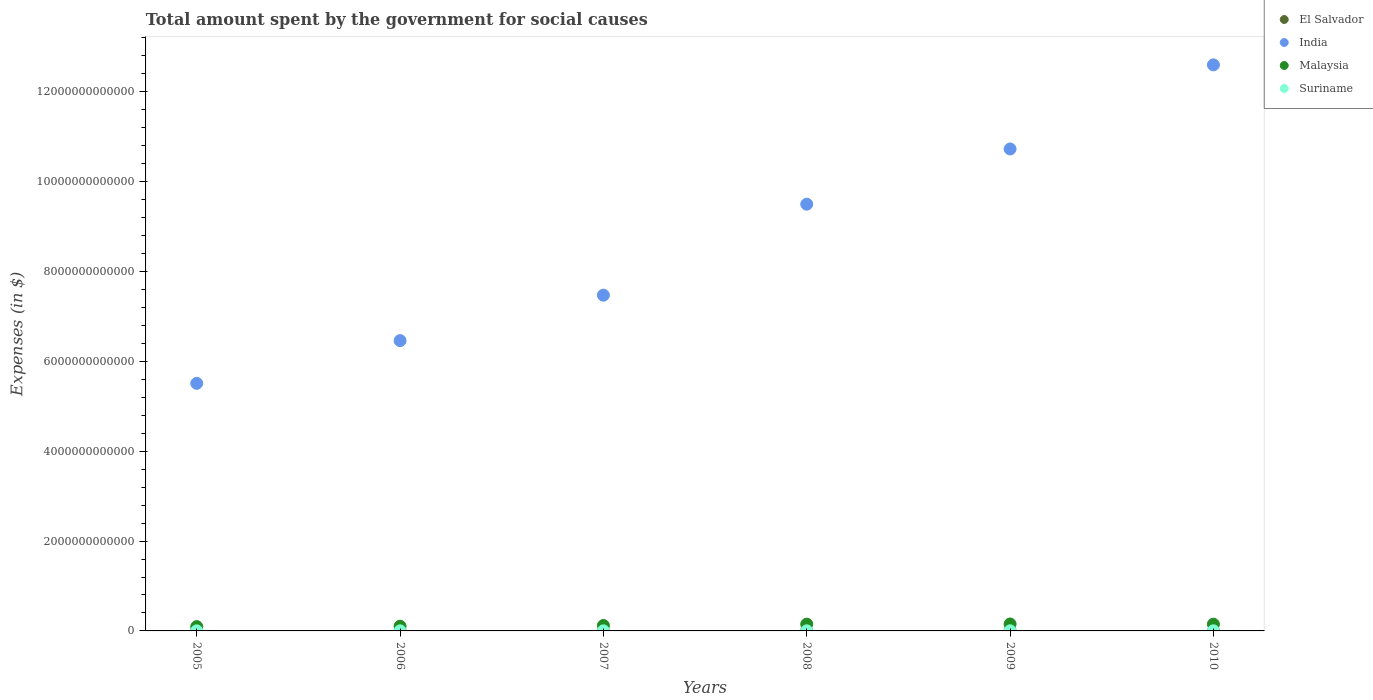Is the number of dotlines equal to the number of legend labels?
Keep it short and to the point. Yes. What is the amount spent for social causes by the government in Malaysia in 2005?
Your response must be concise. 9.61e+1. Across all years, what is the maximum amount spent for social causes by the government in El Salvador?
Offer a terse response. 4.55e+09. Across all years, what is the minimum amount spent for social causes by the government in India?
Give a very brief answer. 5.51e+12. In which year was the amount spent for social causes by the government in El Salvador maximum?
Make the answer very short. 2009. What is the total amount spent for social causes by the government in El Salvador in the graph?
Offer a terse response. 2.32e+1. What is the difference between the amount spent for social causes by the government in El Salvador in 2006 and that in 2007?
Your answer should be very brief. 1.10e+08. What is the difference between the amount spent for social causes by the government in Malaysia in 2005 and the amount spent for social causes by the government in Suriname in 2007?
Your answer should be very brief. 9.43e+1. What is the average amount spent for social causes by the government in El Salvador per year?
Offer a very short reply. 3.87e+09. In the year 2010, what is the difference between the amount spent for social causes by the government in Malaysia and amount spent for social causes by the government in El Salvador?
Provide a short and direct response. 1.45e+11. What is the ratio of the amount spent for social causes by the government in El Salvador in 2005 to that in 2007?
Keep it short and to the point. 0.86. Is the difference between the amount spent for social causes by the government in Malaysia in 2007 and 2008 greater than the difference between the amount spent for social causes by the government in El Salvador in 2007 and 2008?
Provide a succinct answer. No. What is the difference between the highest and the second highest amount spent for social causes by the government in Suriname?
Provide a short and direct response. 3.39e+07. What is the difference between the highest and the lowest amount spent for social causes by the government in India?
Make the answer very short. 7.09e+12. In how many years, is the amount spent for social causes by the government in El Salvador greater than the average amount spent for social causes by the government in El Salvador taken over all years?
Your answer should be very brief. 3. Is the sum of the amount spent for social causes by the government in Suriname in 2006 and 2007 greater than the maximum amount spent for social causes by the government in India across all years?
Provide a short and direct response. No. Does the amount spent for social causes by the government in India monotonically increase over the years?
Ensure brevity in your answer.  Yes. Is the amount spent for social causes by the government in Suriname strictly greater than the amount spent for social causes by the government in El Salvador over the years?
Give a very brief answer. No. How many dotlines are there?
Make the answer very short. 4. How many years are there in the graph?
Your response must be concise. 6. What is the difference between two consecutive major ticks on the Y-axis?
Make the answer very short. 2.00e+12. Are the values on the major ticks of Y-axis written in scientific E-notation?
Provide a short and direct response. No. Does the graph contain grids?
Keep it short and to the point. No. How are the legend labels stacked?
Keep it short and to the point. Vertical. What is the title of the graph?
Offer a very short reply. Total amount spent by the government for social causes. Does "Latin America(developing only)" appear as one of the legend labels in the graph?
Keep it short and to the point. No. What is the label or title of the Y-axis?
Your response must be concise. Expenses (in $). What is the Expenses (in $) of El Salvador in 2005?
Make the answer very short. 3.01e+09. What is the Expenses (in $) in India in 2005?
Make the answer very short. 5.51e+12. What is the Expenses (in $) in Malaysia in 2005?
Your response must be concise. 9.61e+1. What is the Expenses (in $) of Suriname in 2005?
Provide a short and direct response. 1.28e+09. What is the Expenses (in $) of El Salvador in 2006?
Ensure brevity in your answer.  3.60e+09. What is the Expenses (in $) of India in 2006?
Offer a terse response. 6.46e+12. What is the Expenses (in $) in Malaysia in 2006?
Your response must be concise. 1.06e+11. What is the Expenses (in $) in Suriname in 2006?
Ensure brevity in your answer.  1.63e+09. What is the Expenses (in $) in El Salvador in 2007?
Provide a short and direct response. 3.49e+09. What is the Expenses (in $) of India in 2007?
Ensure brevity in your answer.  7.47e+12. What is the Expenses (in $) in Malaysia in 2007?
Your answer should be very brief. 1.21e+11. What is the Expenses (in $) in Suriname in 2007?
Keep it short and to the point. 1.82e+09. What is the Expenses (in $) of El Salvador in 2008?
Make the answer very short. 4.09e+09. What is the Expenses (in $) of India in 2008?
Ensure brevity in your answer.  9.50e+12. What is the Expenses (in $) of Malaysia in 2008?
Offer a terse response. 1.51e+11. What is the Expenses (in $) in Suriname in 2008?
Give a very brief answer. 1.99e+09. What is the Expenses (in $) in El Salvador in 2009?
Provide a succinct answer. 4.55e+09. What is the Expenses (in $) of India in 2009?
Offer a very short reply. 1.07e+13. What is the Expenses (in $) of Malaysia in 2009?
Make the answer very short. 1.54e+11. What is the Expenses (in $) in Suriname in 2009?
Provide a succinct answer. 2.47e+09. What is the Expenses (in $) of El Salvador in 2010?
Keep it short and to the point. 4.45e+09. What is the Expenses (in $) of India in 2010?
Ensure brevity in your answer.  1.26e+13. What is the Expenses (in $) of Malaysia in 2010?
Your response must be concise. 1.50e+11. What is the Expenses (in $) in Suriname in 2010?
Ensure brevity in your answer.  2.50e+09. Across all years, what is the maximum Expenses (in $) of El Salvador?
Make the answer very short. 4.55e+09. Across all years, what is the maximum Expenses (in $) in India?
Offer a terse response. 1.26e+13. Across all years, what is the maximum Expenses (in $) in Malaysia?
Your response must be concise. 1.54e+11. Across all years, what is the maximum Expenses (in $) in Suriname?
Your response must be concise. 2.50e+09. Across all years, what is the minimum Expenses (in $) of El Salvador?
Your response must be concise. 3.01e+09. Across all years, what is the minimum Expenses (in $) in India?
Your answer should be very brief. 5.51e+12. Across all years, what is the minimum Expenses (in $) of Malaysia?
Offer a terse response. 9.61e+1. Across all years, what is the minimum Expenses (in $) of Suriname?
Keep it short and to the point. 1.28e+09. What is the total Expenses (in $) in El Salvador in the graph?
Keep it short and to the point. 2.32e+1. What is the total Expenses (in $) in India in the graph?
Offer a very short reply. 5.23e+13. What is the total Expenses (in $) of Malaysia in the graph?
Provide a succinct answer. 7.77e+11. What is the total Expenses (in $) in Suriname in the graph?
Keep it short and to the point. 1.17e+1. What is the difference between the Expenses (in $) in El Salvador in 2005 and that in 2006?
Provide a short and direct response. -5.95e+08. What is the difference between the Expenses (in $) of India in 2005 and that in 2006?
Provide a succinct answer. -9.51e+11. What is the difference between the Expenses (in $) in Malaysia in 2005 and that in 2006?
Keep it short and to the point. -9.60e+09. What is the difference between the Expenses (in $) in Suriname in 2005 and that in 2006?
Your answer should be compact. -3.43e+08. What is the difference between the Expenses (in $) of El Salvador in 2005 and that in 2007?
Offer a terse response. -4.85e+08. What is the difference between the Expenses (in $) of India in 2005 and that in 2007?
Provide a short and direct response. -1.96e+12. What is the difference between the Expenses (in $) in Malaysia in 2005 and that in 2007?
Ensure brevity in your answer.  -2.44e+1. What is the difference between the Expenses (in $) of Suriname in 2005 and that in 2007?
Offer a terse response. -5.36e+08. What is the difference between the Expenses (in $) in El Salvador in 2005 and that in 2008?
Offer a very short reply. -1.08e+09. What is the difference between the Expenses (in $) of India in 2005 and that in 2008?
Your answer should be very brief. -3.99e+12. What is the difference between the Expenses (in $) of Malaysia in 2005 and that in 2008?
Offer a terse response. -5.45e+1. What is the difference between the Expenses (in $) of Suriname in 2005 and that in 2008?
Ensure brevity in your answer.  -7.04e+08. What is the difference between the Expenses (in $) in El Salvador in 2005 and that in 2009?
Make the answer very short. -1.54e+09. What is the difference between the Expenses (in $) of India in 2005 and that in 2009?
Your answer should be compact. -5.22e+12. What is the difference between the Expenses (in $) in Malaysia in 2005 and that in 2009?
Offer a terse response. -5.83e+1. What is the difference between the Expenses (in $) of Suriname in 2005 and that in 2009?
Provide a short and direct response. -1.18e+09. What is the difference between the Expenses (in $) of El Salvador in 2005 and that in 2010?
Your answer should be compact. -1.44e+09. What is the difference between the Expenses (in $) in India in 2005 and that in 2010?
Your answer should be very brief. -7.09e+12. What is the difference between the Expenses (in $) of Malaysia in 2005 and that in 2010?
Offer a very short reply. -5.36e+1. What is the difference between the Expenses (in $) in Suriname in 2005 and that in 2010?
Offer a terse response. -1.22e+09. What is the difference between the Expenses (in $) of El Salvador in 2006 and that in 2007?
Offer a very short reply. 1.10e+08. What is the difference between the Expenses (in $) in India in 2006 and that in 2007?
Provide a short and direct response. -1.01e+12. What is the difference between the Expenses (in $) in Malaysia in 2006 and that in 2007?
Provide a succinct answer. -1.48e+1. What is the difference between the Expenses (in $) of Suriname in 2006 and that in 2007?
Make the answer very short. -1.93e+08. What is the difference between the Expenses (in $) of El Salvador in 2006 and that in 2008?
Give a very brief answer. -4.88e+08. What is the difference between the Expenses (in $) of India in 2006 and that in 2008?
Provide a succinct answer. -3.04e+12. What is the difference between the Expenses (in $) of Malaysia in 2006 and that in 2008?
Ensure brevity in your answer.  -4.49e+1. What is the difference between the Expenses (in $) of Suriname in 2006 and that in 2008?
Your answer should be compact. -3.61e+08. What is the difference between the Expenses (in $) of El Salvador in 2006 and that in 2009?
Offer a very short reply. -9.46e+08. What is the difference between the Expenses (in $) of India in 2006 and that in 2009?
Ensure brevity in your answer.  -4.27e+12. What is the difference between the Expenses (in $) of Malaysia in 2006 and that in 2009?
Your answer should be very brief. -4.87e+1. What is the difference between the Expenses (in $) of Suriname in 2006 and that in 2009?
Make the answer very short. -8.41e+08. What is the difference between the Expenses (in $) of El Salvador in 2006 and that in 2010?
Provide a succinct answer. -8.50e+08. What is the difference between the Expenses (in $) in India in 2006 and that in 2010?
Offer a terse response. -6.14e+12. What is the difference between the Expenses (in $) in Malaysia in 2006 and that in 2010?
Your answer should be very brief. -4.40e+1. What is the difference between the Expenses (in $) of Suriname in 2006 and that in 2010?
Your response must be concise. -8.75e+08. What is the difference between the Expenses (in $) in El Salvador in 2007 and that in 2008?
Give a very brief answer. -5.98e+08. What is the difference between the Expenses (in $) in India in 2007 and that in 2008?
Keep it short and to the point. -2.03e+12. What is the difference between the Expenses (in $) of Malaysia in 2007 and that in 2008?
Your response must be concise. -3.01e+1. What is the difference between the Expenses (in $) of Suriname in 2007 and that in 2008?
Make the answer very short. -1.68e+08. What is the difference between the Expenses (in $) in El Salvador in 2007 and that in 2009?
Ensure brevity in your answer.  -1.06e+09. What is the difference between the Expenses (in $) of India in 2007 and that in 2009?
Offer a terse response. -3.25e+12. What is the difference between the Expenses (in $) of Malaysia in 2007 and that in 2009?
Ensure brevity in your answer.  -3.39e+1. What is the difference between the Expenses (in $) of Suriname in 2007 and that in 2009?
Your answer should be compact. -6.49e+08. What is the difference between the Expenses (in $) in El Salvador in 2007 and that in 2010?
Offer a very short reply. -9.60e+08. What is the difference between the Expenses (in $) of India in 2007 and that in 2010?
Your answer should be very brief. -5.13e+12. What is the difference between the Expenses (in $) of Malaysia in 2007 and that in 2010?
Make the answer very short. -2.92e+1. What is the difference between the Expenses (in $) in Suriname in 2007 and that in 2010?
Provide a succinct answer. -6.83e+08. What is the difference between the Expenses (in $) of El Salvador in 2008 and that in 2009?
Offer a terse response. -4.58e+08. What is the difference between the Expenses (in $) of India in 2008 and that in 2009?
Ensure brevity in your answer.  -1.23e+12. What is the difference between the Expenses (in $) in Malaysia in 2008 and that in 2009?
Your response must be concise. -3.82e+09. What is the difference between the Expenses (in $) of Suriname in 2008 and that in 2009?
Ensure brevity in your answer.  -4.80e+08. What is the difference between the Expenses (in $) of El Salvador in 2008 and that in 2010?
Offer a very short reply. -3.62e+08. What is the difference between the Expenses (in $) in India in 2008 and that in 2010?
Make the answer very short. -3.10e+12. What is the difference between the Expenses (in $) in Malaysia in 2008 and that in 2010?
Give a very brief answer. 9.00e+08. What is the difference between the Expenses (in $) in Suriname in 2008 and that in 2010?
Provide a succinct answer. -5.14e+08. What is the difference between the Expenses (in $) in El Salvador in 2009 and that in 2010?
Give a very brief answer. 9.62e+07. What is the difference between the Expenses (in $) of India in 2009 and that in 2010?
Offer a very short reply. -1.87e+12. What is the difference between the Expenses (in $) of Malaysia in 2009 and that in 2010?
Offer a terse response. 4.72e+09. What is the difference between the Expenses (in $) of Suriname in 2009 and that in 2010?
Make the answer very short. -3.39e+07. What is the difference between the Expenses (in $) of El Salvador in 2005 and the Expenses (in $) of India in 2006?
Your answer should be very brief. -6.46e+12. What is the difference between the Expenses (in $) in El Salvador in 2005 and the Expenses (in $) in Malaysia in 2006?
Provide a succinct answer. -1.03e+11. What is the difference between the Expenses (in $) in El Salvador in 2005 and the Expenses (in $) in Suriname in 2006?
Make the answer very short. 1.38e+09. What is the difference between the Expenses (in $) of India in 2005 and the Expenses (in $) of Malaysia in 2006?
Ensure brevity in your answer.  5.41e+12. What is the difference between the Expenses (in $) in India in 2005 and the Expenses (in $) in Suriname in 2006?
Your answer should be compact. 5.51e+12. What is the difference between the Expenses (in $) in Malaysia in 2005 and the Expenses (in $) in Suriname in 2006?
Give a very brief answer. 9.45e+1. What is the difference between the Expenses (in $) in El Salvador in 2005 and the Expenses (in $) in India in 2007?
Your answer should be compact. -7.47e+12. What is the difference between the Expenses (in $) of El Salvador in 2005 and the Expenses (in $) of Malaysia in 2007?
Give a very brief answer. -1.18e+11. What is the difference between the Expenses (in $) of El Salvador in 2005 and the Expenses (in $) of Suriname in 2007?
Your answer should be compact. 1.19e+09. What is the difference between the Expenses (in $) of India in 2005 and the Expenses (in $) of Malaysia in 2007?
Make the answer very short. 5.39e+12. What is the difference between the Expenses (in $) in India in 2005 and the Expenses (in $) in Suriname in 2007?
Your answer should be compact. 5.51e+12. What is the difference between the Expenses (in $) in Malaysia in 2005 and the Expenses (in $) in Suriname in 2007?
Offer a terse response. 9.43e+1. What is the difference between the Expenses (in $) in El Salvador in 2005 and the Expenses (in $) in India in 2008?
Make the answer very short. -9.50e+12. What is the difference between the Expenses (in $) in El Salvador in 2005 and the Expenses (in $) in Malaysia in 2008?
Give a very brief answer. -1.48e+11. What is the difference between the Expenses (in $) in El Salvador in 2005 and the Expenses (in $) in Suriname in 2008?
Your answer should be very brief. 1.02e+09. What is the difference between the Expenses (in $) of India in 2005 and the Expenses (in $) of Malaysia in 2008?
Offer a very short reply. 5.36e+12. What is the difference between the Expenses (in $) in India in 2005 and the Expenses (in $) in Suriname in 2008?
Ensure brevity in your answer.  5.51e+12. What is the difference between the Expenses (in $) of Malaysia in 2005 and the Expenses (in $) of Suriname in 2008?
Ensure brevity in your answer.  9.42e+1. What is the difference between the Expenses (in $) in El Salvador in 2005 and the Expenses (in $) in India in 2009?
Ensure brevity in your answer.  -1.07e+13. What is the difference between the Expenses (in $) of El Salvador in 2005 and the Expenses (in $) of Malaysia in 2009?
Provide a succinct answer. -1.51e+11. What is the difference between the Expenses (in $) of El Salvador in 2005 and the Expenses (in $) of Suriname in 2009?
Your answer should be compact. 5.42e+08. What is the difference between the Expenses (in $) in India in 2005 and the Expenses (in $) in Malaysia in 2009?
Keep it short and to the point. 5.36e+12. What is the difference between the Expenses (in $) in India in 2005 and the Expenses (in $) in Suriname in 2009?
Ensure brevity in your answer.  5.51e+12. What is the difference between the Expenses (in $) of Malaysia in 2005 and the Expenses (in $) of Suriname in 2009?
Make the answer very short. 9.37e+1. What is the difference between the Expenses (in $) of El Salvador in 2005 and the Expenses (in $) of India in 2010?
Give a very brief answer. -1.26e+13. What is the difference between the Expenses (in $) of El Salvador in 2005 and the Expenses (in $) of Malaysia in 2010?
Your answer should be compact. -1.47e+11. What is the difference between the Expenses (in $) in El Salvador in 2005 and the Expenses (in $) in Suriname in 2010?
Offer a terse response. 5.08e+08. What is the difference between the Expenses (in $) of India in 2005 and the Expenses (in $) of Malaysia in 2010?
Your response must be concise. 5.36e+12. What is the difference between the Expenses (in $) in India in 2005 and the Expenses (in $) in Suriname in 2010?
Your answer should be compact. 5.51e+12. What is the difference between the Expenses (in $) in Malaysia in 2005 and the Expenses (in $) in Suriname in 2010?
Offer a terse response. 9.36e+1. What is the difference between the Expenses (in $) of El Salvador in 2006 and the Expenses (in $) of India in 2007?
Offer a terse response. -7.47e+12. What is the difference between the Expenses (in $) in El Salvador in 2006 and the Expenses (in $) in Malaysia in 2007?
Provide a succinct answer. -1.17e+11. What is the difference between the Expenses (in $) in El Salvador in 2006 and the Expenses (in $) in Suriname in 2007?
Offer a very short reply. 1.79e+09. What is the difference between the Expenses (in $) in India in 2006 and the Expenses (in $) in Malaysia in 2007?
Keep it short and to the point. 6.34e+12. What is the difference between the Expenses (in $) of India in 2006 and the Expenses (in $) of Suriname in 2007?
Your response must be concise. 6.46e+12. What is the difference between the Expenses (in $) of Malaysia in 2006 and the Expenses (in $) of Suriname in 2007?
Your answer should be very brief. 1.04e+11. What is the difference between the Expenses (in $) of El Salvador in 2006 and the Expenses (in $) of India in 2008?
Your response must be concise. -9.50e+12. What is the difference between the Expenses (in $) in El Salvador in 2006 and the Expenses (in $) in Malaysia in 2008?
Provide a succinct answer. -1.47e+11. What is the difference between the Expenses (in $) in El Salvador in 2006 and the Expenses (in $) in Suriname in 2008?
Offer a very short reply. 1.62e+09. What is the difference between the Expenses (in $) in India in 2006 and the Expenses (in $) in Malaysia in 2008?
Your answer should be compact. 6.31e+12. What is the difference between the Expenses (in $) in India in 2006 and the Expenses (in $) in Suriname in 2008?
Keep it short and to the point. 6.46e+12. What is the difference between the Expenses (in $) of Malaysia in 2006 and the Expenses (in $) of Suriname in 2008?
Give a very brief answer. 1.04e+11. What is the difference between the Expenses (in $) in El Salvador in 2006 and the Expenses (in $) in India in 2009?
Make the answer very short. -1.07e+13. What is the difference between the Expenses (in $) in El Salvador in 2006 and the Expenses (in $) in Malaysia in 2009?
Your answer should be compact. -1.51e+11. What is the difference between the Expenses (in $) of El Salvador in 2006 and the Expenses (in $) of Suriname in 2009?
Offer a terse response. 1.14e+09. What is the difference between the Expenses (in $) in India in 2006 and the Expenses (in $) in Malaysia in 2009?
Provide a short and direct response. 6.31e+12. What is the difference between the Expenses (in $) in India in 2006 and the Expenses (in $) in Suriname in 2009?
Offer a terse response. 6.46e+12. What is the difference between the Expenses (in $) in Malaysia in 2006 and the Expenses (in $) in Suriname in 2009?
Offer a very short reply. 1.03e+11. What is the difference between the Expenses (in $) in El Salvador in 2006 and the Expenses (in $) in India in 2010?
Make the answer very short. -1.26e+13. What is the difference between the Expenses (in $) of El Salvador in 2006 and the Expenses (in $) of Malaysia in 2010?
Ensure brevity in your answer.  -1.46e+11. What is the difference between the Expenses (in $) of El Salvador in 2006 and the Expenses (in $) of Suriname in 2010?
Give a very brief answer. 1.10e+09. What is the difference between the Expenses (in $) in India in 2006 and the Expenses (in $) in Malaysia in 2010?
Provide a short and direct response. 6.31e+12. What is the difference between the Expenses (in $) in India in 2006 and the Expenses (in $) in Suriname in 2010?
Make the answer very short. 6.46e+12. What is the difference between the Expenses (in $) in Malaysia in 2006 and the Expenses (in $) in Suriname in 2010?
Your answer should be compact. 1.03e+11. What is the difference between the Expenses (in $) in El Salvador in 2007 and the Expenses (in $) in India in 2008?
Provide a short and direct response. -9.50e+12. What is the difference between the Expenses (in $) in El Salvador in 2007 and the Expenses (in $) in Malaysia in 2008?
Keep it short and to the point. -1.47e+11. What is the difference between the Expenses (in $) in El Salvador in 2007 and the Expenses (in $) in Suriname in 2008?
Provide a short and direct response. 1.51e+09. What is the difference between the Expenses (in $) in India in 2007 and the Expenses (in $) in Malaysia in 2008?
Your response must be concise. 7.32e+12. What is the difference between the Expenses (in $) of India in 2007 and the Expenses (in $) of Suriname in 2008?
Your answer should be compact. 7.47e+12. What is the difference between the Expenses (in $) of Malaysia in 2007 and the Expenses (in $) of Suriname in 2008?
Keep it short and to the point. 1.19e+11. What is the difference between the Expenses (in $) of El Salvador in 2007 and the Expenses (in $) of India in 2009?
Offer a terse response. -1.07e+13. What is the difference between the Expenses (in $) of El Salvador in 2007 and the Expenses (in $) of Malaysia in 2009?
Keep it short and to the point. -1.51e+11. What is the difference between the Expenses (in $) in El Salvador in 2007 and the Expenses (in $) in Suriname in 2009?
Offer a very short reply. 1.03e+09. What is the difference between the Expenses (in $) of India in 2007 and the Expenses (in $) of Malaysia in 2009?
Your response must be concise. 7.32e+12. What is the difference between the Expenses (in $) in India in 2007 and the Expenses (in $) in Suriname in 2009?
Your answer should be very brief. 7.47e+12. What is the difference between the Expenses (in $) in Malaysia in 2007 and the Expenses (in $) in Suriname in 2009?
Offer a terse response. 1.18e+11. What is the difference between the Expenses (in $) in El Salvador in 2007 and the Expenses (in $) in India in 2010?
Your response must be concise. -1.26e+13. What is the difference between the Expenses (in $) in El Salvador in 2007 and the Expenses (in $) in Malaysia in 2010?
Offer a terse response. -1.46e+11. What is the difference between the Expenses (in $) of El Salvador in 2007 and the Expenses (in $) of Suriname in 2010?
Your answer should be very brief. 9.93e+08. What is the difference between the Expenses (in $) in India in 2007 and the Expenses (in $) in Malaysia in 2010?
Provide a short and direct response. 7.32e+12. What is the difference between the Expenses (in $) in India in 2007 and the Expenses (in $) in Suriname in 2010?
Provide a short and direct response. 7.47e+12. What is the difference between the Expenses (in $) in Malaysia in 2007 and the Expenses (in $) in Suriname in 2010?
Provide a succinct answer. 1.18e+11. What is the difference between the Expenses (in $) in El Salvador in 2008 and the Expenses (in $) in India in 2009?
Ensure brevity in your answer.  -1.07e+13. What is the difference between the Expenses (in $) of El Salvador in 2008 and the Expenses (in $) of Malaysia in 2009?
Give a very brief answer. -1.50e+11. What is the difference between the Expenses (in $) of El Salvador in 2008 and the Expenses (in $) of Suriname in 2009?
Offer a terse response. 1.62e+09. What is the difference between the Expenses (in $) in India in 2008 and the Expenses (in $) in Malaysia in 2009?
Offer a terse response. 9.35e+12. What is the difference between the Expenses (in $) in India in 2008 and the Expenses (in $) in Suriname in 2009?
Provide a succinct answer. 9.50e+12. What is the difference between the Expenses (in $) of Malaysia in 2008 and the Expenses (in $) of Suriname in 2009?
Make the answer very short. 1.48e+11. What is the difference between the Expenses (in $) of El Salvador in 2008 and the Expenses (in $) of India in 2010?
Ensure brevity in your answer.  -1.26e+13. What is the difference between the Expenses (in $) of El Salvador in 2008 and the Expenses (in $) of Malaysia in 2010?
Provide a short and direct response. -1.46e+11. What is the difference between the Expenses (in $) of El Salvador in 2008 and the Expenses (in $) of Suriname in 2010?
Your answer should be compact. 1.59e+09. What is the difference between the Expenses (in $) of India in 2008 and the Expenses (in $) of Malaysia in 2010?
Provide a succinct answer. 9.35e+12. What is the difference between the Expenses (in $) of India in 2008 and the Expenses (in $) of Suriname in 2010?
Keep it short and to the point. 9.50e+12. What is the difference between the Expenses (in $) in Malaysia in 2008 and the Expenses (in $) in Suriname in 2010?
Provide a short and direct response. 1.48e+11. What is the difference between the Expenses (in $) of El Salvador in 2009 and the Expenses (in $) of India in 2010?
Your answer should be very brief. -1.26e+13. What is the difference between the Expenses (in $) in El Salvador in 2009 and the Expenses (in $) in Malaysia in 2010?
Ensure brevity in your answer.  -1.45e+11. What is the difference between the Expenses (in $) in El Salvador in 2009 and the Expenses (in $) in Suriname in 2010?
Make the answer very short. 2.05e+09. What is the difference between the Expenses (in $) in India in 2009 and the Expenses (in $) in Malaysia in 2010?
Your response must be concise. 1.06e+13. What is the difference between the Expenses (in $) of India in 2009 and the Expenses (in $) of Suriname in 2010?
Offer a terse response. 1.07e+13. What is the difference between the Expenses (in $) in Malaysia in 2009 and the Expenses (in $) in Suriname in 2010?
Your response must be concise. 1.52e+11. What is the average Expenses (in $) of El Salvador per year?
Keep it short and to the point. 3.87e+09. What is the average Expenses (in $) in India per year?
Your answer should be very brief. 8.71e+12. What is the average Expenses (in $) in Malaysia per year?
Ensure brevity in your answer.  1.30e+11. What is the average Expenses (in $) in Suriname per year?
Your answer should be very brief. 1.95e+09. In the year 2005, what is the difference between the Expenses (in $) of El Salvador and Expenses (in $) of India?
Your answer should be very brief. -5.51e+12. In the year 2005, what is the difference between the Expenses (in $) in El Salvador and Expenses (in $) in Malaysia?
Offer a terse response. -9.31e+1. In the year 2005, what is the difference between the Expenses (in $) of El Salvador and Expenses (in $) of Suriname?
Give a very brief answer. 1.73e+09. In the year 2005, what is the difference between the Expenses (in $) of India and Expenses (in $) of Malaysia?
Provide a succinct answer. 5.42e+12. In the year 2005, what is the difference between the Expenses (in $) in India and Expenses (in $) in Suriname?
Give a very brief answer. 5.51e+12. In the year 2005, what is the difference between the Expenses (in $) in Malaysia and Expenses (in $) in Suriname?
Offer a very short reply. 9.49e+1. In the year 2006, what is the difference between the Expenses (in $) in El Salvador and Expenses (in $) in India?
Provide a succinct answer. -6.46e+12. In the year 2006, what is the difference between the Expenses (in $) of El Salvador and Expenses (in $) of Malaysia?
Your response must be concise. -1.02e+11. In the year 2006, what is the difference between the Expenses (in $) in El Salvador and Expenses (in $) in Suriname?
Your answer should be very brief. 1.98e+09. In the year 2006, what is the difference between the Expenses (in $) of India and Expenses (in $) of Malaysia?
Ensure brevity in your answer.  6.36e+12. In the year 2006, what is the difference between the Expenses (in $) in India and Expenses (in $) in Suriname?
Your answer should be very brief. 6.46e+12. In the year 2006, what is the difference between the Expenses (in $) of Malaysia and Expenses (in $) of Suriname?
Make the answer very short. 1.04e+11. In the year 2007, what is the difference between the Expenses (in $) in El Salvador and Expenses (in $) in India?
Your answer should be compact. -7.47e+12. In the year 2007, what is the difference between the Expenses (in $) in El Salvador and Expenses (in $) in Malaysia?
Your answer should be compact. -1.17e+11. In the year 2007, what is the difference between the Expenses (in $) of El Salvador and Expenses (in $) of Suriname?
Your response must be concise. 1.68e+09. In the year 2007, what is the difference between the Expenses (in $) of India and Expenses (in $) of Malaysia?
Your answer should be compact. 7.35e+12. In the year 2007, what is the difference between the Expenses (in $) in India and Expenses (in $) in Suriname?
Provide a short and direct response. 7.47e+12. In the year 2007, what is the difference between the Expenses (in $) of Malaysia and Expenses (in $) of Suriname?
Your response must be concise. 1.19e+11. In the year 2008, what is the difference between the Expenses (in $) in El Salvador and Expenses (in $) in India?
Provide a succinct answer. -9.50e+12. In the year 2008, what is the difference between the Expenses (in $) in El Salvador and Expenses (in $) in Malaysia?
Give a very brief answer. -1.47e+11. In the year 2008, what is the difference between the Expenses (in $) of El Salvador and Expenses (in $) of Suriname?
Provide a short and direct response. 2.10e+09. In the year 2008, what is the difference between the Expenses (in $) in India and Expenses (in $) in Malaysia?
Your response must be concise. 9.35e+12. In the year 2008, what is the difference between the Expenses (in $) in India and Expenses (in $) in Suriname?
Provide a short and direct response. 9.50e+12. In the year 2008, what is the difference between the Expenses (in $) in Malaysia and Expenses (in $) in Suriname?
Offer a terse response. 1.49e+11. In the year 2009, what is the difference between the Expenses (in $) in El Salvador and Expenses (in $) in India?
Keep it short and to the point. -1.07e+13. In the year 2009, what is the difference between the Expenses (in $) in El Salvador and Expenses (in $) in Malaysia?
Offer a terse response. -1.50e+11. In the year 2009, what is the difference between the Expenses (in $) of El Salvador and Expenses (in $) of Suriname?
Give a very brief answer. 2.08e+09. In the year 2009, what is the difference between the Expenses (in $) of India and Expenses (in $) of Malaysia?
Give a very brief answer. 1.06e+13. In the year 2009, what is the difference between the Expenses (in $) of India and Expenses (in $) of Suriname?
Make the answer very short. 1.07e+13. In the year 2009, what is the difference between the Expenses (in $) of Malaysia and Expenses (in $) of Suriname?
Your answer should be very brief. 1.52e+11. In the year 2010, what is the difference between the Expenses (in $) in El Salvador and Expenses (in $) in India?
Make the answer very short. -1.26e+13. In the year 2010, what is the difference between the Expenses (in $) of El Salvador and Expenses (in $) of Malaysia?
Keep it short and to the point. -1.45e+11. In the year 2010, what is the difference between the Expenses (in $) in El Salvador and Expenses (in $) in Suriname?
Make the answer very short. 1.95e+09. In the year 2010, what is the difference between the Expenses (in $) in India and Expenses (in $) in Malaysia?
Provide a short and direct response. 1.25e+13. In the year 2010, what is the difference between the Expenses (in $) of India and Expenses (in $) of Suriname?
Keep it short and to the point. 1.26e+13. In the year 2010, what is the difference between the Expenses (in $) in Malaysia and Expenses (in $) in Suriname?
Keep it short and to the point. 1.47e+11. What is the ratio of the Expenses (in $) of El Salvador in 2005 to that in 2006?
Provide a succinct answer. 0.83. What is the ratio of the Expenses (in $) of India in 2005 to that in 2006?
Ensure brevity in your answer.  0.85. What is the ratio of the Expenses (in $) in Malaysia in 2005 to that in 2006?
Provide a short and direct response. 0.91. What is the ratio of the Expenses (in $) in Suriname in 2005 to that in 2006?
Ensure brevity in your answer.  0.79. What is the ratio of the Expenses (in $) of El Salvador in 2005 to that in 2007?
Your answer should be compact. 0.86. What is the ratio of the Expenses (in $) in India in 2005 to that in 2007?
Offer a very short reply. 0.74. What is the ratio of the Expenses (in $) of Malaysia in 2005 to that in 2007?
Your answer should be compact. 0.8. What is the ratio of the Expenses (in $) of Suriname in 2005 to that in 2007?
Offer a very short reply. 0.71. What is the ratio of the Expenses (in $) of El Salvador in 2005 to that in 2008?
Your answer should be compact. 0.74. What is the ratio of the Expenses (in $) in India in 2005 to that in 2008?
Provide a succinct answer. 0.58. What is the ratio of the Expenses (in $) in Malaysia in 2005 to that in 2008?
Keep it short and to the point. 0.64. What is the ratio of the Expenses (in $) of Suriname in 2005 to that in 2008?
Provide a succinct answer. 0.65. What is the ratio of the Expenses (in $) of El Salvador in 2005 to that in 2009?
Offer a very short reply. 0.66. What is the ratio of the Expenses (in $) in India in 2005 to that in 2009?
Make the answer very short. 0.51. What is the ratio of the Expenses (in $) of Malaysia in 2005 to that in 2009?
Provide a succinct answer. 0.62. What is the ratio of the Expenses (in $) of Suriname in 2005 to that in 2009?
Make the answer very short. 0.52. What is the ratio of the Expenses (in $) in El Salvador in 2005 to that in 2010?
Your answer should be very brief. 0.68. What is the ratio of the Expenses (in $) in India in 2005 to that in 2010?
Offer a very short reply. 0.44. What is the ratio of the Expenses (in $) in Malaysia in 2005 to that in 2010?
Give a very brief answer. 0.64. What is the ratio of the Expenses (in $) of Suriname in 2005 to that in 2010?
Ensure brevity in your answer.  0.51. What is the ratio of the Expenses (in $) in El Salvador in 2006 to that in 2007?
Offer a terse response. 1.03. What is the ratio of the Expenses (in $) of India in 2006 to that in 2007?
Give a very brief answer. 0.86. What is the ratio of the Expenses (in $) in Malaysia in 2006 to that in 2007?
Your answer should be compact. 0.88. What is the ratio of the Expenses (in $) of Suriname in 2006 to that in 2007?
Your response must be concise. 0.89. What is the ratio of the Expenses (in $) in El Salvador in 2006 to that in 2008?
Your answer should be compact. 0.88. What is the ratio of the Expenses (in $) in India in 2006 to that in 2008?
Provide a succinct answer. 0.68. What is the ratio of the Expenses (in $) of Malaysia in 2006 to that in 2008?
Provide a succinct answer. 0.7. What is the ratio of the Expenses (in $) of Suriname in 2006 to that in 2008?
Ensure brevity in your answer.  0.82. What is the ratio of the Expenses (in $) of El Salvador in 2006 to that in 2009?
Keep it short and to the point. 0.79. What is the ratio of the Expenses (in $) of India in 2006 to that in 2009?
Ensure brevity in your answer.  0.6. What is the ratio of the Expenses (in $) of Malaysia in 2006 to that in 2009?
Offer a very short reply. 0.68. What is the ratio of the Expenses (in $) of Suriname in 2006 to that in 2009?
Make the answer very short. 0.66. What is the ratio of the Expenses (in $) of El Salvador in 2006 to that in 2010?
Keep it short and to the point. 0.81. What is the ratio of the Expenses (in $) of India in 2006 to that in 2010?
Your answer should be compact. 0.51. What is the ratio of the Expenses (in $) in Malaysia in 2006 to that in 2010?
Your answer should be compact. 0.71. What is the ratio of the Expenses (in $) of Suriname in 2006 to that in 2010?
Offer a terse response. 0.65. What is the ratio of the Expenses (in $) in El Salvador in 2007 to that in 2008?
Offer a terse response. 0.85. What is the ratio of the Expenses (in $) of India in 2007 to that in 2008?
Make the answer very short. 0.79. What is the ratio of the Expenses (in $) in Malaysia in 2007 to that in 2008?
Your response must be concise. 0.8. What is the ratio of the Expenses (in $) of Suriname in 2007 to that in 2008?
Give a very brief answer. 0.92. What is the ratio of the Expenses (in $) in El Salvador in 2007 to that in 2009?
Keep it short and to the point. 0.77. What is the ratio of the Expenses (in $) in India in 2007 to that in 2009?
Your answer should be compact. 0.7. What is the ratio of the Expenses (in $) of Malaysia in 2007 to that in 2009?
Keep it short and to the point. 0.78. What is the ratio of the Expenses (in $) in Suriname in 2007 to that in 2009?
Offer a very short reply. 0.74. What is the ratio of the Expenses (in $) in El Salvador in 2007 to that in 2010?
Keep it short and to the point. 0.78. What is the ratio of the Expenses (in $) of India in 2007 to that in 2010?
Keep it short and to the point. 0.59. What is the ratio of the Expenses (in $) of Malaysia in 2007 to that in 2010?
Your answer should be compact. 0.8. What is the ratio of the Expenses (in $) of Suriname in 2007 to that in 2010?
Give a very brief answer. 0.73. What is the ratio of the Expenses (in $) in El Salvador in 2008 to that in 2009?
Provide a succinct answer. 0.9. What is the ratio of the Expenses (in $) of India in 2008 to that in 2009?
Your response must be concise. 0.89. What is the ratio of the Expenses (in $) in Malaysia in 2008 to that in 2009?
Your answer should be very brief. 0.98. What is the ratio of the Expenses (in $) of Suriname in 2008 to that in 2009?
Provide a succinct answer. 0.81. What is the ratio of the Expenses (in $) of El Salvador in 2008 to that in 2010?
Provide a short and direct response. 0.92. What is the ratio of the Expenses (in $) of India in 2008 to that in 2010?
Your response must be concise. 0.75. What is the ratio of the Expenses (in $) of Malaysia in 2008 to that in 2010?
Provide a short and direct response. 1.01. What is the ratio of the Expenses (in $) of Suriname in 2008 to that in 2010?
Make the answer very short. 0.79. What is the ratio of the Expenses (in $) in El Salvador in 2009 to that in 2010?
Your response must be concise. 1.02. What is the ratio of the Expenses (in $) in India in 2009 to that in 2010?
Ensure brevity in your answer.  0.85. What is the ratio of the Expenses (in $) of Malaysia in 2009 to that in 2010?
Provide a succinct answer. 1.03. What is the ratio of the Expenses (in $) in Suriname in 2009 to that in 2010?
Your answer should be very brief. 0.99. What is the difference between the highest and the second highest Expenses (in $) in El Salvador?
Provide a short and direct response. 9.62e+07. What is the difference between the highest and the second highest Expenses (in $) in India?
Offer a terse response. 1.87e+12. What is the difference between the highest and the second highest Expenses (in $) of Malaysia?
Keep it short and to the point. 3.82e+09. What is the difference between the highest and the second highest Expenses (in $) in Suriname?
Offer a very short reply. 3.39e+07. What is the difference between the highest and the lowest Expenses (in $) in El Salvador?
Offer a terse response. 1.54e+09. What is the difference between the highest and the lowest Expenses (in $) in India?
Provide a succinct answer. 7.09e+12. What is the difference between the highest and the lowest Expenses (in $) in Malaysia?
Offer a very short reply. 5.83e+1. What is the difference between the highest and the lowest Expenses (in $) of Suriname?
Offer a very short reply. 1.22e+09. 